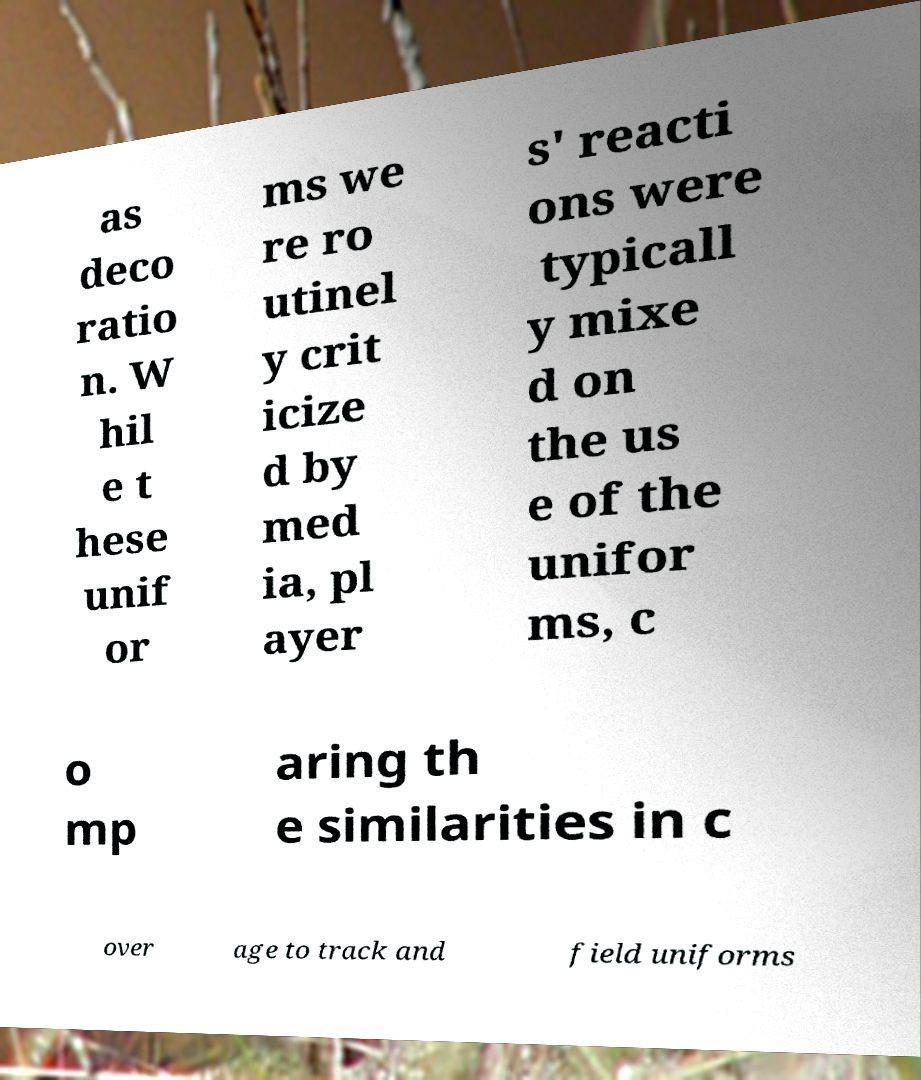Please identify and transcribe the text found in this image. as deco ratio n. W hil e t hese unif or ms we re ro utinel y crit icize d by med ia, pl ayer s' reacti ons were typicall y mixe d on the us e of the unifor ms, c o mp aring th e similarities in c over age to track and field uniforms 